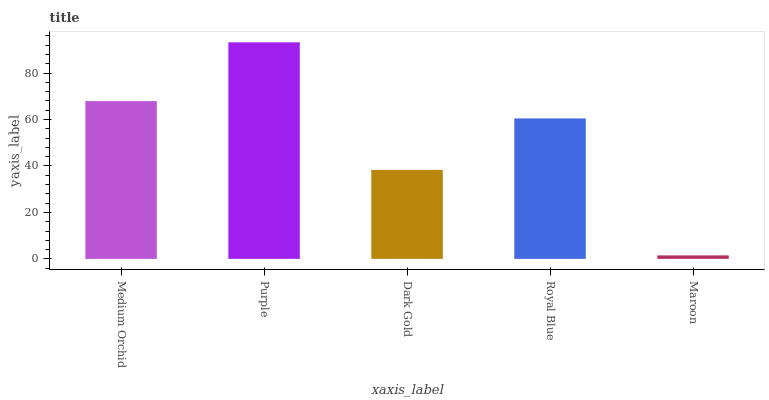Is Maroon the minimum?
Answer yes or no. Yes. Is Purple the maximum?
Answer yes or no. Yes. Is Dark Gold the minimum?
Answer yes or no. No. Is Dark Gold the maximum?
Answer yes or no. No. Is Purple greater than Dark Gold?
Answer yes or no. Yes. Is Dark Gold less than Purple?
Answer yes or no. Yes. Is Dark Gold greater than Purple?
Answer yes or no. No. Is Purple less than Dark Gold?
Answer yes or no. No. Is Royal Blue the high median?
Answer yes or no. Yes. Is Royal Blue the low median?
Answer yes or no. Yes. Is Purple the high median?
Answer yes or no. No. Is Purple the low median?
Answer yes or no. No. 